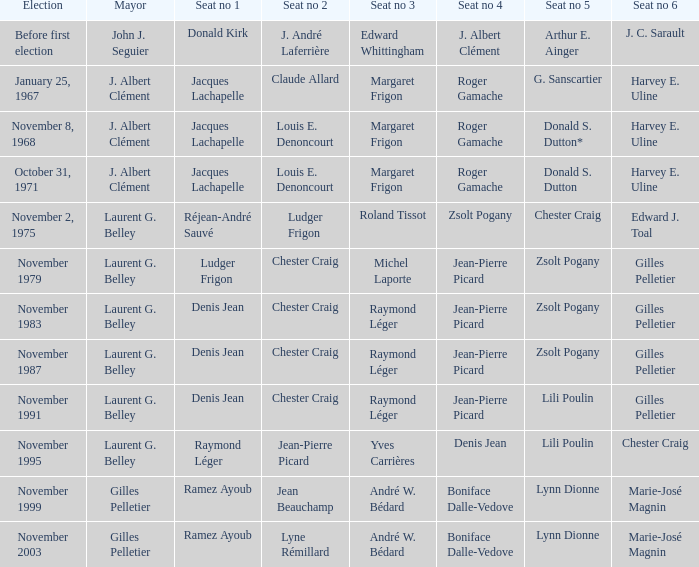Who was in seat no 1 when john j. seguier was the mayor? Donald Kirk. 